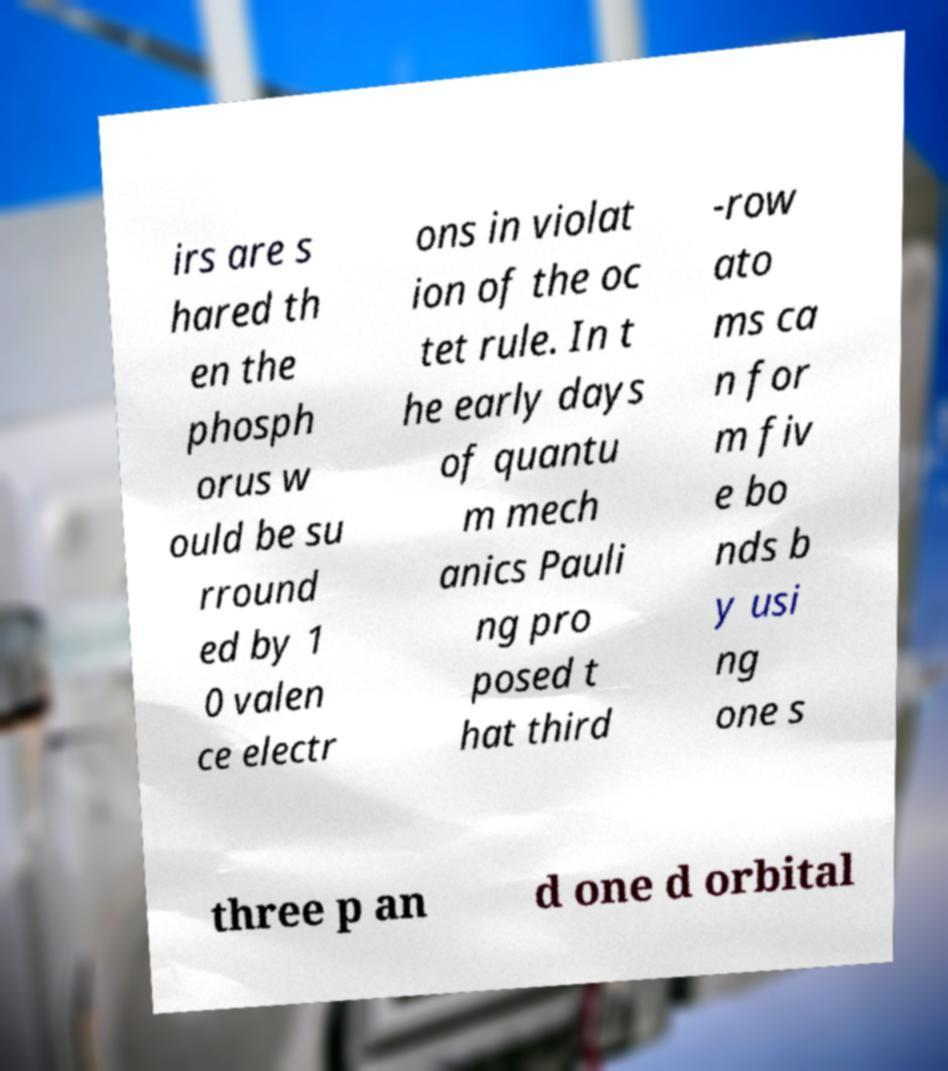I need the written content from this picture converted into text. Can you do that? irs are s hared th en the phosph orus w ould be su rround ed by 1 0 valen ce electr ons in violat ion of the oc tet rule. In t he early days of quantu m mech anics Pauli ng pro posed t hat third -row ato ms ca n for m fiv e bo nds b y usi ng one s three p an d one d orbital 